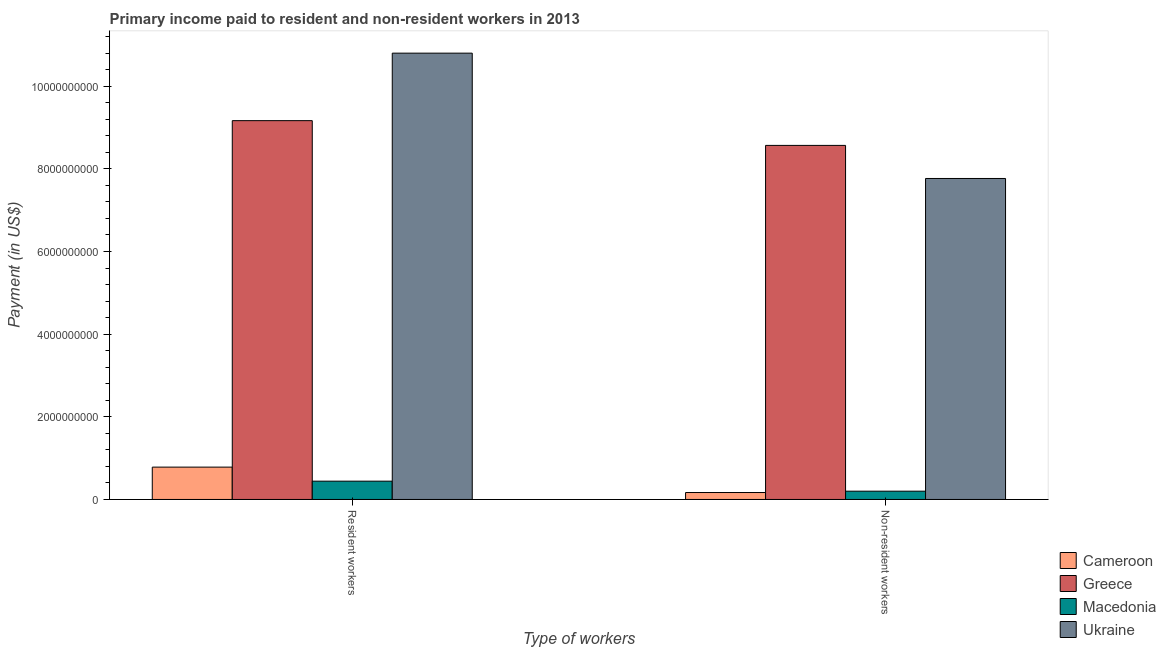How many different coloured bars are there?
Provide a short and direct response. 4. How many groups of bars are there?
Your answer should be compact. 2. How many bars are there on the 1st tick from the right?
Provide a short and direct response. 4. What is the label of the 2nd group of bars from the left?
Ensure brevity in your answer.  Non-resident workers. What is the payment made to resident workers in Ukraine?
Offer a very short reply. 1.08e+1. Across all countries, what is the maximum payment made to resident workers?
Provide a short and direct response. 1.08e+1. Across all countries, what is the minimum payment made to non-resident workers?
Give a very brief answer. 1.68e+08. In which country was the payment made to resident workers maximum?
Your answer should be very brief. Ukraine. In which country was the payment made to resident workers minimum?
Provide a short and direct response. Macedonia. What is the total payment made to resident workers in the graph?
Offer a very short reply. 2.12e+1. What is the difference between the payment made to resident workers in Macedonia and that in Ukraine?
Provide a short and direct response. -1.04e+1. What is the difference between the payment made to resident workers in Greece and the payment made to non-resident workers in Cameroon?
Provide a succinct answer. 9.00e+09. What is the average payment made to non-resident workers per country?
Your answer should be very brief. 4.18e+09. What is the difference between the payment made to non-resident workers and payment made to resident workers in Ukraine?
Keep it short and to the point. -3.03e+09. In how many countries, is the payment made to non-resident workers greater than 6000000000 US$?
Offer a very short reply. 2. What is the ratio of the payment made to non-resident workers in Greece to that in Ukraine?
Your answer should be very brief. 1.1. Is the payment made to resident workers in Macedonia less than that in Ukraine?
Offer a very short reply. Yes. What does the 2nd bar from the right in Resident workers represents?
Provide a succinct answer. Macedonia. What is the difference between two consecutive major ticks on the Y-axis?
Your answer should be very brief. 2.00e+09. Does the graph contain any zero values?
Make the answer very short. No. Does the graph contain grids?
Your answer should be very brief. No. Where does the legend appear in the graph?
Your response must be concise. Bottom right. What is the title of the graph?
Your answer should be very brief. Primary income paid to resident and non-resident workers in 2013. Does "Seychelles" appear as one of the legend labels in the graph?
Your answer should be compact. No. What is the label or title of the X-axis?
Offer a terse response. Type of workers. What is the label or title of the Y-axis?
Keep it short and to the point. Payment (in US$). What is the Payment (in US$) in Cameroon in Resident workers?
Keep it short and to the point. 7.83e+08. What is the Payment (in US$) of Greece in Resident workers?
Give a very brief answer. 9.17e+09. What is the Payment (in US$) of Macedonia in Resident workers?
Provide a short and direct response. 4.43e+08. What is the Payment (in US$) of Ukraine in Resident workers?
Offer a terse response. 1.08e+1. What is the Payment (in US$) of Cameroon in Non-resident workers?
Provide a short and direct response. 1.68e+08. What is the Payment (in US$) of Greece in Non-resident workers?
Keep it short and to the point. 8.57e+09. What is the Payment (in US$) of Macedonia in Non-resident workers?
Give a very brief answer. 2.01e+08. What is the Payment (in US$) of Ukraine in Non-resident workers?
Offer a terse response. 7.77e+09. Across all Type of workers, what is the maximum Payment (in US$) in Cameroon?
Your answer should be very brief. 7.83e+08. Across all Type of workers, what is the maximum Payment (in US$) of Greece?
Ensure brevity in your answer.  9.17e+09. Across all Type of workers, what is the maximum Payment (in US$) in Macedonia?
Offer a very short reply. 4.43e+08. Across all Type of workers, what is the maximum Payment (in US$) in Ukraine?
Your answer should be compact. 1.08e+1. Across all Type of workers, what is the minimum Payment (in US$) in Cameroon?
Your answer should be very brief. 1.68e+08. Across all Type of workers, what is the minimum Payment (in US$) in Greece?
Provide a short and direct response. 8.57e+09. Across all Type of workers, what is the minimum Payment (in US$) in Macedonia?
Give a very brief answer. 2.01e+08. Across all Type of workers, what is the minimum Payment (in US$) in Ukraine?
Offer a terse response. 7.77e+09. What is the total Payment (in US$) of Cameroon in the graph?
Your answer should be very brief. 9.50e+08. What is the total Payment (in US$) in Greece in the graph?
Provide a short and direct response. 1.77e+1. What is the total Payment (in US$) of Macedonia in the graph?
Your response must be concise. 6.43e+08. What is the total Payment (in US$) in Ukraine in the graph?
Offer a terse response. 1.86e+1. What is the difference between the Payment (in US$) in Cameroon in Resident workers and that in Non-resident workers?
Give a very brief answer. 6.15e+08. What is the difference between the Payment (in US$) of Greece in Resident workers and that in Non-resident workers?
Ensure brevity in your answer.  5.99e+08. What is the difference between the Payment (in US$) in Macedonia in Resident workers and that in Non-resident workers?
Provide a short and direct response. 2.42e+08. What is the difference between the Payment (in US$) of Ukraine in Resident workers and that in Non-resident workers?
Your answer should be compact. 3.03e+09. What is the difference between the Payment (in US$) in Cameroon in Resident workers and the Payment (in US$) in Greece in Non-resident workers?
Your response must be concise. -7.78e+09. What is the difference between the Payment (in US$) in Cameroon in Resident workers and the Payment (in US$) in Macedonia in Non-resident workers?
Ensure brevity in your answer.  5.82e+08. What is the difference between the Payment (in US$) of Cameroon in Resident workers and the Payment (in US$) of Ukraine in Non-resident workers?
Provide a succinct answer. -6.98e+09. What is the difference between the Payment (in US$) of Greece in Resident workers and the Payment (in US$) of Macedonia in Non-resident workers?
Offer a terse response. 8.97e+09. What is the difference between the Payment (in US$) of Greece in Resident workers and the Payment (in US$) of Ukraine in Non-resident workers?
Keep it short and to the point. 1.40e+09. What is the difference between the Payment (in US$) of Macedonia in Resident workers and the Payment (in US$) of Ukraine in Non-resident workers?
Provide a short and direct response. -7.32e+09. What is the average Payment (in US$) of Cameroon per Type of workers?
Ensure brevity in your answer.  4.75e+08. What is the average Payment (in US$) of Greece per Type of workers?
Your answer should be compact. 8.87e+09. What is the average Payment (in US$) in Macedonia per Type of workers?
Your answer should be very brief. 3.22e+08. What is the average Payment (in US$) of Ukraine per Type of workers?
Keep it short and to the point. 9.28e+09. What is the difference between the Payment (in US$) of Cameroon and Payment (in US$) of Greece in Resident workers?
Offer a very short reply. -8.38e+09. What is the difference between the Payment (in US$) in Cameroon and Payment (in US$) in Macedonia in Resident workers?
Give a very brief answer. 3.40e+08. What is the difference between the Payment (in US$) of Cameroon and Payment (in US$) of Ukraine in Resident workers?
Your answer should be very brief. -1.00e+1. What is the difference between the Payment (in US$) of Greece and Payment (in US$) of Macedonia in Resident workers?
Offer a very short reply. 8.72e+09. What is the difference between the Payment (in US$) of Greece and Payment (in US$) of Ukraine in Resident workers?
Provide a short and direct response. -1.63e+09. What is the difference between the Payment (in US$) in Macedonia and Payment (in US$) in Ukraine in Resident workers?
Provide a short and direct response. -1.04e+1. What is the difference between the Payment (in US$) of Cameroon and Payment (in US$) of Greece in Non-resident workers?
Offer a terse response. -8.40e+09. What is the difference between the Payment (in US$) in Cameroon and Payment (in US$) in Macedonia in Non-resident workers?
Offer a very short reply. -3.28e+07. What is the difference between the Payment (in US$) of Cameroon and Payment (in US$) of Ukraine in Non-resident workers?
Offer a terse response. -7.60e+09. What is the difference between the Payment (in US$) in Greece and Payment (in US$) in Macedonia in Non-resident workers?
Keep it short and to the point. 8.37e+09. What is the difference between the Payment (in US$) of Greece and Payment (in US$) of Ukraine in Non-resident workers?
Keep it short and to the point. 8.00e+08. What is the difference between the Payment (in US$) of Macedonia and Payment (in US$) of Ukraine in Non-resident workers?
Offer a terse response. -7.57e+09. What is the ratio of the Payment (in US$) of Cameroon in Resident workers to that in Non-resident workers?
Provide a succinct answer. 4.67. What is the ratio of the Payment (in US$) of Greece in Resident workers to that in Non-resident workers?
Keep it short and to the point. 1.07. What is the ratio of the Payment (in US$) in Macedonia in Resident workers to that in Non-resident workers?
Provide a succinct answer. 2.21. What is the ratio of the Payment (in US$) of Ukraine in Resident workers to that in Non-resident workers?
Your answer should be compact. 1.39. What is the difference between the highest and the second highest Payment (in US$) of Cameroon?
Offer a very short reply. 6.15e+08. What is the difference between the highest and the second highest Payment (in US$) in Greece?
Ensure brevity in your answer.  5.99e+08. What is the difference between the highest and the second highest Payment (in US$) in Macedonia?
Make the answer very short. 2.42e+08. What is the difference between the highest and the second highest Payment (in US$) in Ukraine?
Give a very brief answer. 3.03e+09. What is the difference between the highest and the lowest Payment (in US$) of Cameroon?
Offer a very short reply. 6.15e+08. What is the difference between the highest and the lowest Payment (in US$) of Greece?
Give a very brief answer. 5.99e+08. What is the difference between the highest and the lowest Payment (in US$) of Macedonia?
Keep it short and to the point. 2.42e+08. What is the difference between the highest and the lowest Payment (in US$) of Ukraine?
Offer a very short reply. 3.03e+09. 